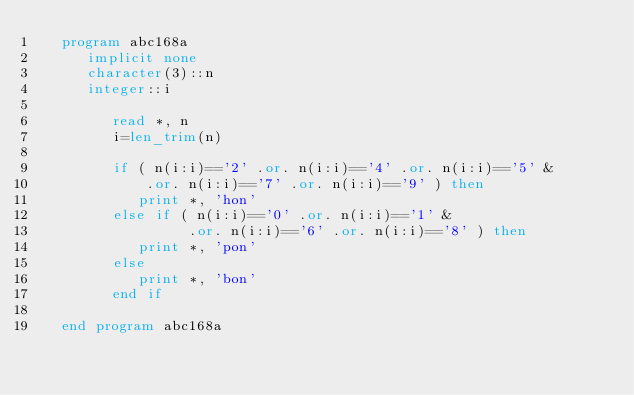<code> <loc_0><loc_0><loc_500><loc_500><_FORTRAN_>   program abc168a
      implicit none
      character(3)::n
      integer::i

         read *, n
         i=len_trim(n)

         if ( n(i:i)=='2' .or. n(i:i)=='4' .or. n(i:i)=='5' &
             .or. n(i:i)=='7' .or. n(i:i)=='9' ) then
            print *, 'hon'
         else if ( n(i:i)=='0' .or. n(i:i)=='1' &
                  .or. n(i:i)=='6' .or. n(i:i)=='8' ) then
            print *, 'pon'
         else
            print *, 'bon'
         end if

   end program abc168a</code> 